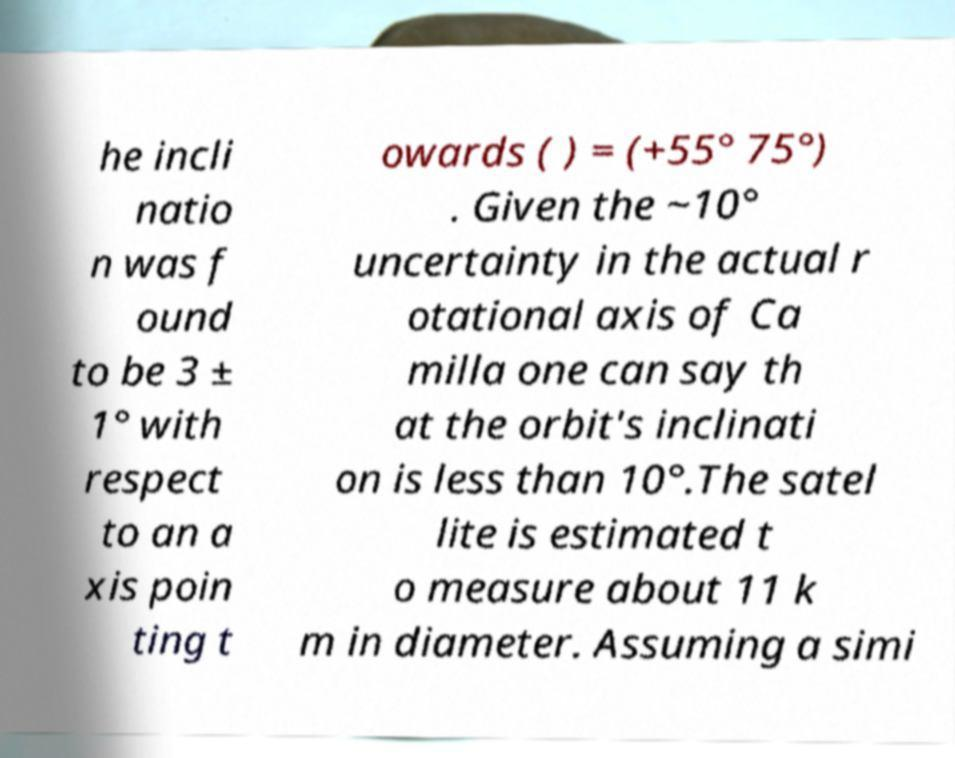Can you accurately transcribe the text from the provided image for me? he incli natio n was f ound to be 3 ± 1° with respect to an a xis poin ting t owards ( ) = (+55° 75°) . Given the ~10° uncertainty in the actual r otational axis of Ca milla one can say th at the orbit's inclinati on is less than 10°.The satel lite is estimated t o measure about 11 k m in diameter. Assuming a simi 